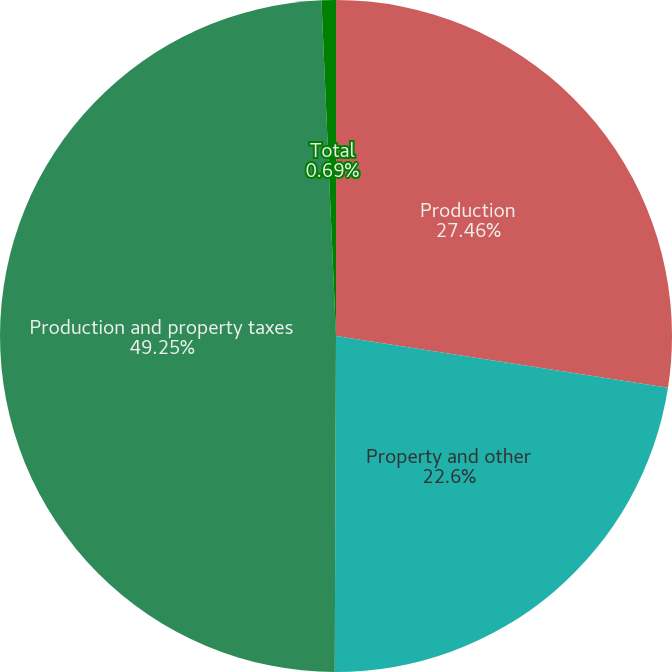<chart> <loc_0><loc_0><loc_500><loc_500><pie_chart><fcel>Production<fcel>Property and other<fcel>Production and property taxes<fcel>Total<nl><fcel>27.46%<fcel>22.6%<fcel>49.25%<fcel>0.69%<nl></chart> 